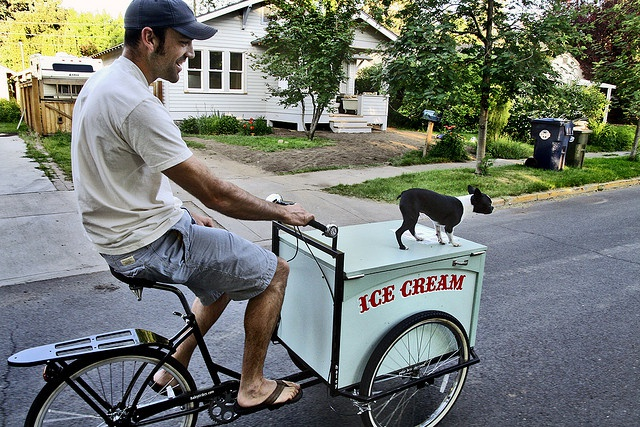Describe the objects in this image and their specific colors. I can see bicycle in darkgreen, black, darkgray, and lightblue tones, people in darkgreen, darkgray, black, gray, and lavender tones, dog in darkgreen, black, lightgray, darkgray, and gray tones, and truck in darkgreen, white, black, darkgray, and gray tones in this image. 